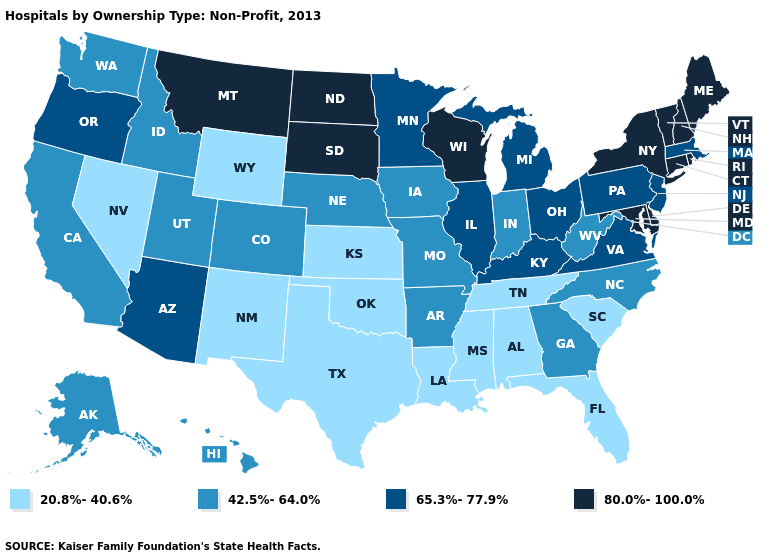Among the states that border Utah , does New Mexico have the lowest value?
Answer briefly. Yes. Does the first symbol in the legend represent the smallest category?
Quick response, please. Yes. Does Iowa have a higher value than Oklahoma?
Give a very brief answer. Yes. Does New Hampshire have the highest value in the Northeast?
Answer briefly. Yes. Which states have the highest value in the USA?
Be succinct. Connecticut, Delaware, Maine, Maryland, Montana, New Hampshire, New York, North Dakota, Rhode Island, South Dakota, Vermont, Wisconsin. What is the value of Illinois?
Concise answer only. 65.3%-77.9%. Name the states that have a value in the range 20.8%-40.6%?
Answer briefly. Alabama, Florida, Kansas, Louisiana, Mississippi, Nevada, New Mexico, Oklahoma, South Carolina, Tennessee, Texas, Wyoming. What is the value of North Carolina?
Keep it brief. 42.5%-64.0%. What is the highest value in the West ?
Give a very brief answer. 80.0%-100.0%. Does Nebraska have a higher value than Oklahoma?
Short answer required. Yes. What is the highest value in states that border Idaho?
Answer briefly. 80.0%-100.0%. Does Oregon have a lower value than Wisconsin?
Answer briefly. Yes. What is the highest value in the USA?
Write a very short answer. 80.0%-100.0%. What is the value of Nebraska?
Write a very short answer. 42.5%-64.0%. Is the legend a continuous bar?
Be succinct. No. 